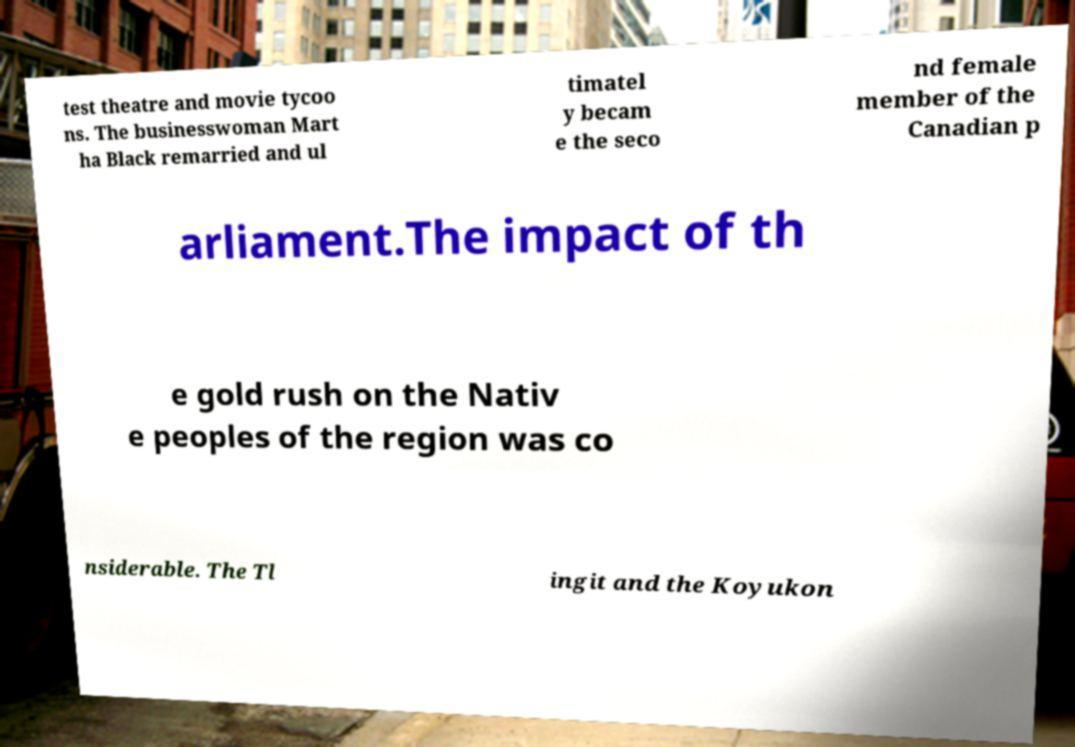I need the written content from this picture converted into text. Can you do that? test theatre and movie tycoo ns. The businesswoman Mart ha Black remarried and ul timatel y becam e the seco nd female member of the Canadian p arliament.The impact of th e gold rush on the Nativ e peoples of the region was co nsiderable. The Tl ingit and the Koyukon 